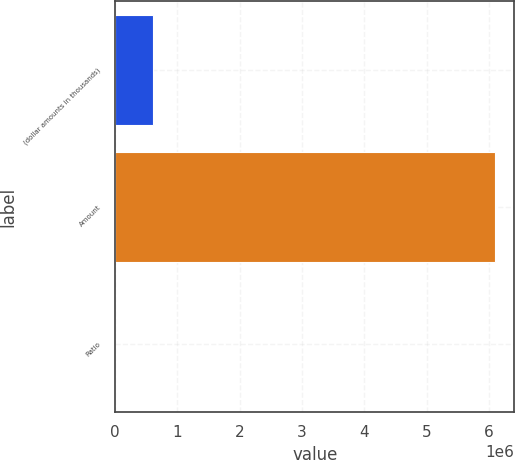Convert chart to OTSL. <chart><loc_0><loc_0><loc_500><loc_500><bar_chart><fcel>(dollar amounts in thousands)<fcel>Amount<fcel>Ratio<nl><fcel>609972<fcel>6.09963e+06<fcel>10.67<nl></chart> 